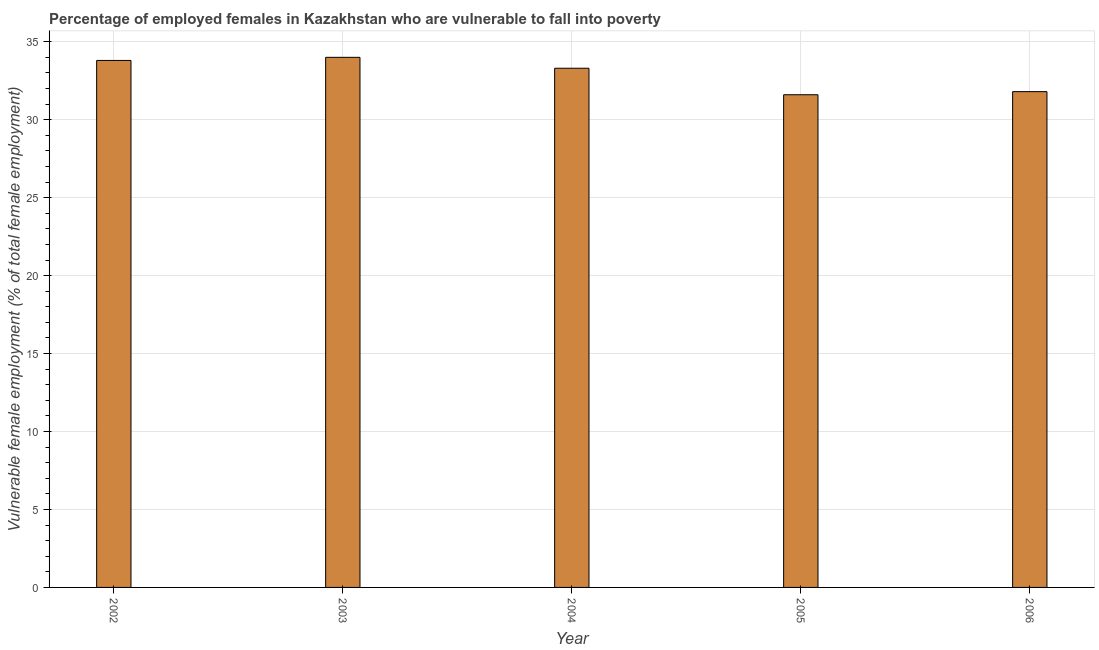Does the graph contain any zero values?
Offer a very short reply. No. What is the title of the graph?
Make the answer very short. Percentage of employed females in Kazakhstan who are vulnerable to fall into poverty. What is the label or title of the Y-axis?
Give a very brief answer. Vulnerable female employment (% of total female employment). What is the percentage of employed females who are vulnerable to fall into poverty in 2006?
Provide a short and direct response. 31.8. Across all years, what is the maximum percentage of employed females who are vulnerable to fall into poverty?
Offer a terse response. 34. Across all years, what is the minimum percentage of employed females who are vulnerable to fall into poverty?
Your answer should be very brief. 31.6. In which year was the percentage of employed females who are vulnerable to fall into poverty maximum?
Provide a succinct answer. 2003. What is the sum of the percentage of employed females who are vulnerable to fall into poverty?
Give a very brief answer. 164.5. What is the difference between the percentage of employed females who are vulnerable to fall into poverty in 2005 and 2006?
Offer a terse response. -0.2. What is the average percentage of employed females who are vulnerable to fall into poverty per year?
Your response must be concise. 32.9. What is the median percentage of employed females who are vulnerable to fall into poverty?
Offer a very short reply. 33.3. In how many years, is the percentage of employed females who are vulnerable to fall into poverty greater than 26 %?
Offer a terse response. 5. What is the ratio of the percentage of employed females who are vulnerable to fall into poverty in 2003 to that in 2005?
Make the answer very short. 1.08. Is the difference between the percentage of employed females who are vulnerable to fall into poverty in 2004 and 2006 greater than the difference between any two years?
Ensure brevity in your answer.  No. Is the sum of the percentage of employed females who are vulnerable to fall into poverty in 2002 and 2005 greater than the maximum percentage of employed females who are vulnerable to fall into poverty across all years?
Your response must be concise. Yes. What is the difference between the highest and the lowest percentage of employed females who are vulnerable to fall into poverty?
Provide a succinct answer. 2.4. Are all the bars in the graph horizontal?
Offer a very short reply. No. What is the Vulnerable female employment (% of total female employment) of 2002?
Your answer should be very brief. 33.8. What is the Vulnerable female employment (% of total female employment) of 2004?
Keep it short and to the point. 33.3. What is the Vulnerable female employment (% of total female employment) of 2005?
Make the answer very short. 31.6. What is the Vulnerable female employment (% of total female employment) of 2006?
Your answer should be compact. 31.8. What is the difference between the Vulnerable female employment (% of total female employment) in 2002 and 2004?
Provide a short and direct response. 0.5. What is the difference between the Vulnerable female employment (% of total female employment) in 2002 and 2005?
Your answer should be very brief. 2.2. What is the difference between the Vulnerable female employment (% of total female employment) in 2002 and 2006?
Your answer should be very brief. 2. What is the difference between the Vulnerable female employment (% of total female employment) in 2003 and 2006?
Provide a succinct answer. 2.2. What is the difference between the Vulnerable female employment (% of total female employment) in 2004 and 2006?
Your response must be concise. 1.5. What is the ratio of the Vulnerable female employment (% of total female employment) in 2002 to that in 2004?
Make the answer very short. 1.01. What is the ratio of the Vulnerable female employment (% of total female employment) in 2002 to that in 2005?
Ensure brevity in your answer.  1.07. What is the ratio of the Vulnerable female employment (% of total female employment) in 2002 to that in 2006?
Keep it short and to the point. 1.06. What is the ratio of the Vulnerable female employment (% of total female employment) in 2003 to that in 2004?
Your answer should be compact. 1.02. What is the ratio of the Vulnerable female employment (% of total female employment) in 2003 to that in 2005?
Ensure brevity in your answer.  1.08. What is the ratio of the Vulnerable female employment (% of total female employment) in 2003 to that in 2006?
Provide a succinct answer. 1.07. What is the ratio of the Vulnerable female employment (% of total female employment) in 2004 to that in 2005?
Your response must be concise. 1.05. What is the ratio of the Vulnerable female employment (% of total female employment) in 2004 to that in 2006?
Provide a succinct answer. 1.05. 